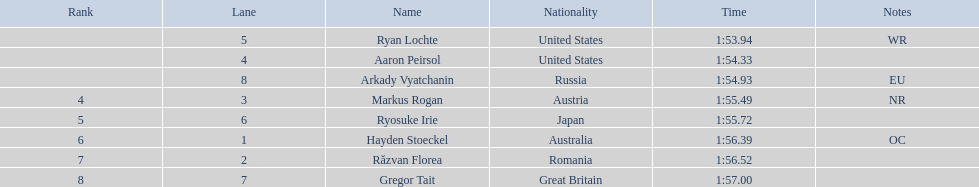Which competitor was the last to place? Gregor Tait. 